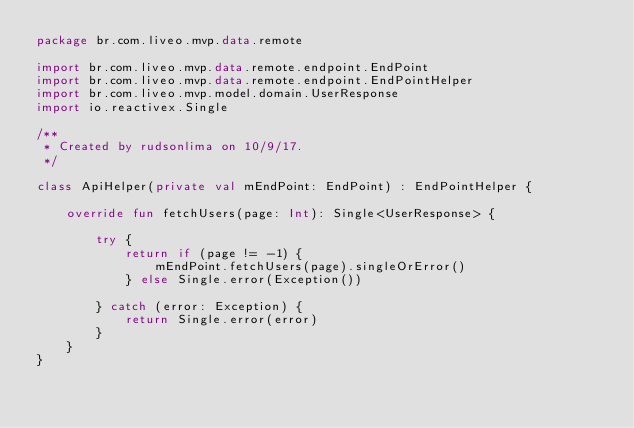<code> <loc_0><loc_0><loc_500><loc_500><_Kotlin_>package br.com.liveo.mvp.data.remote

import br.com.liveo.mvp.data.remote.endpoint.EndPoint
import br.com.liveo.mvp.data.remote.endpoint.EndPointHelper
import br.com.liveo.mvp.model.domain.UserResponse
import io.reactivex.Single

/**
 * Created by rudsonlima on 10/9/17.
 */

class ApiHelper(private val mEndPoint: EndPoint) : EndPointHelper {

    override fun fetchUsers(page: Int): Single<UserResponse> {

        try {
            return if (page != -1) {
                mEndPoint.fetchUsers(page).singleOrError()
            } else Single.error(Exception())

        } catch (error: Exception) {
            return Single.error(error)
        }
    }
}
</code> 